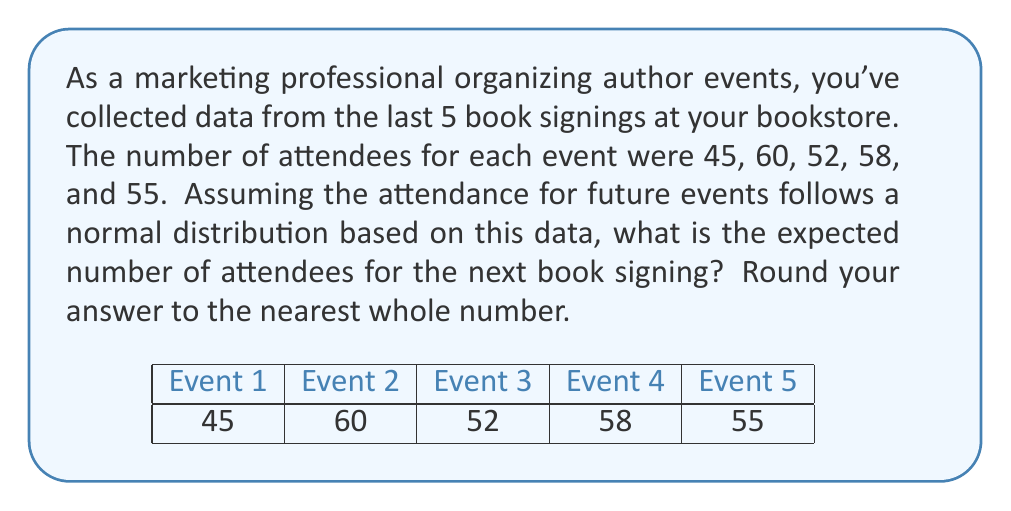Could you help me with this problem? To solve this problem, we need to calculate the mean of the given data, which will serve as the expected value for the normal distribution. Here's the step-by-step process:

1. List the given data points:
   45, 60, 52, 58, 55

2. Calculate the mean (μ) using the formula:
   $$ \mu = \frac{\sum_{i=1}^{n} x_i}{n} $$
   Where $x_i$ are the individual data points and $n$ is the number of data points.

3. Sum up all the data points:
   $$ \sum_{i=1}^{n} x_i = 45 + 60 + 52 + 58 + 55 = 270 $$

4. Divide by the number of data points (n = 5):
   $$ \mu = \frac{270}{5} = 54 $$

5. Round to the nearest whole number:
   54 (no rounding necessary in this case)

The expected number of attendees for the next book signing, based on the normal distribution derived from past events, is 54.
Answer: 54 attendees 